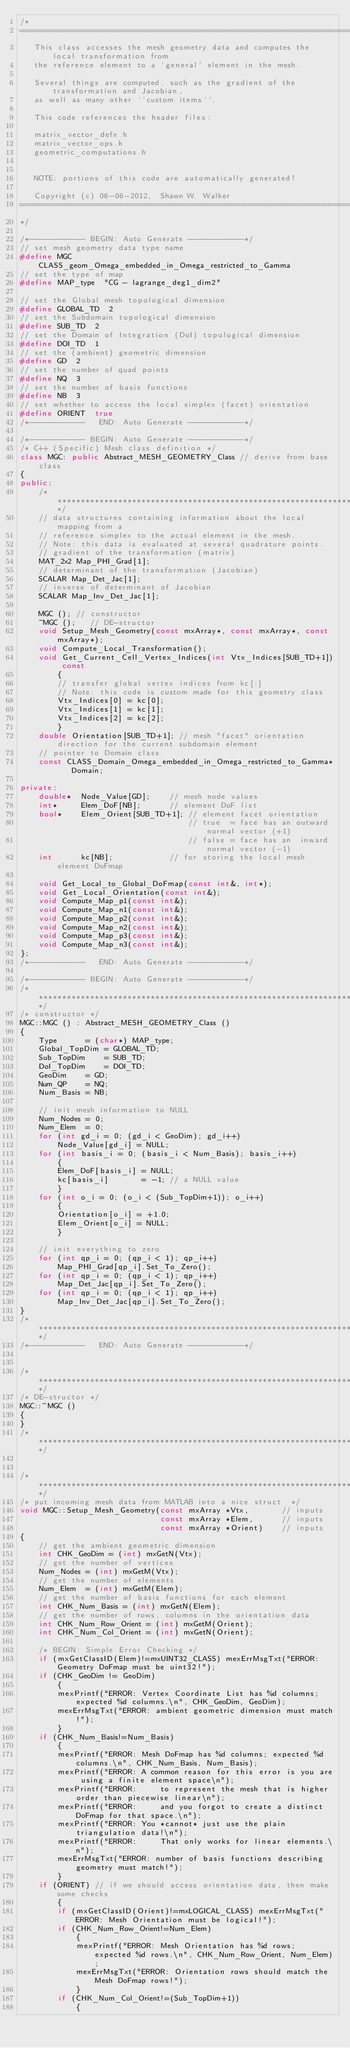<code> <loc_0><loc_0><loc_500><loc_500><_C++_>/*
============================================================================================
   This class accesses the mesh geometry data and computes the local transformation from
   the reference element to a `general' element in the mesh.
   
   Several things are computed, such as the gradient of the transformation and Jacobian,
   as well as many other ``custom items''.
   
   This code references the header files:
   
   matrix_vector_defn.h
   matrix_vector_ops.h
   geometric_computations.h
   

   NOTE: portions of this code are automatically generated!

   Copyright (c) 06-06-2012,  Shawn W. Walker
============================================================================================
*/

/*------------ BEGIN: Auto Generate ------------*/
// set mesh geometry data type name
#define MGC        CLASS_geom_Omega_embedded_in_Omega_restricted_to_Gamma
// set the type of map
#define MAP_type  "CG - lagrange_deg1_dim2"

// set the Global mesh topological dimension
#define GLOBAL_TD  2
// set the Subdomain topological dimension
#define SUB_TD  2
// set the Domain of Integration (DoI) topological dimension
#define DOI_TD  1
// set the (ambient) geometric dimension
#define GD  2
// set the number of quad points
#define NQ  3
// set the number of basis functions
#define NB  3
// set whether to access the local simplex (facet) orientation
#define ORIENT  true
/*------------   END: Auto Generate ------------*/

/*------------ BEGIN: Auto Generate ------------*/
/* C++ (Specific) Mesh class definition */
class MGC: public Abstract_MESH_GEOMETRY_Class // derive from base class
{
public:
    /***************************************************************************************/
    // data structures containing information about the local mapping from a
    // reference simplex to the actual element in the mesh.
    // Note: this data is evaluated at several quadrature points.
    // gradient of the transformation (matrix)
    MAT_2x2 Map_PHI_Grad[1];
    // determinant of the transformation (Jacobian)
    SCALAR Map_Det_Jac[1];
    // inverse of determinant of Jacobian
    SCALAR Map_Inv_Det_Jac[1];

    MGC (); // constructor
    ~MGC ();   // DE-structor
    void Setup_Mesh_Geometry(const mxArray*, const mxArray*, const mxArray*);
    void Compute_Local_Transformation();
    void Get_Current_Cell_Vertex_Indices(int Vtx_Indices[SUB_TD+1]) const
        {
        // transfer global vertex indices from kc[:]
        // Note: this code is custom made for this geometry class
        Vtx_Indices[0] = kc[0];
        Vtx_Indices[1] = kc[1];
        Vtx_Indices[2] = kc[2];
        }
    double Orientation[SUB_TD+1]; // mesh "facet" orientation direction for the current subdomain element
    // pointer to Domain class
    const CLASS_Domain_Omega_embedded_in_Omega_restricted_to_Gamma*   Domain;

private:
    double*  Node_Value[GD];    // mesh node values
    int*     Elem_DoF[NB];      // element DoF list
    bool*    Elem_Orient[SUB_TD+1]; // element facet orientation
                                    // true  = face has an outward normal vector (+1)
                                    // false = face has an  inward normal vector (-1)
    int      kc[NB];            // for storing the local mesh element DoFmap

    void Get_Local_to_Global_DoFmap(const int&, int*);
    void Get_Local_Orientation(const int&);
    void Compute_Map_p1(const int&);
    void Compute_Map_n1(const int&);
    void Compute_Map_p2(const int&);
    void Compute_Map_n2(const int&);
    void Compute_Map_p3(const int&);
    void Compute_Map_n3(const int&);
};
/*------------   END: Auto Generate ------------*/

/*------------ BEGIN: Auto Generate ------------*/
/***************************************************************************************/
/* constructor */
MGC::MGC () : Abstract_MESH_GEOMETRY_Class ()
{
    Type      = (char*) MAP_type;
    Global_TopDim = GLOBAL_TD;
    Sub_TopDim    = SUB_TD;
    DoI_TopDim    = DOI_TD;
    GeoDim    = GD;
    Num_QP    = NQ;
    Num_Basis = NB;

    // init mesh information to NULL
    Num_Nodes = 0;
    Num_Elem  = 0;
    for (int gd_i = 0; (gd_i < GeoDim); gd_i++)
        Node_Value[gd_i] = NULL;
    for (int basis_i = 0; (basis_i < Num_Basis); basis_i++)
        {
        Elem_DoF[basis_i] = NULL;
        kc[basis_i]       = -1; // a NULL value
        }
    for (int o_i = 0; (o_i < (Sub_TopDim+1)); o_i++)
        {
        Orientation[o_i] = +1.0;
        Elem_Orient[o_i] = NULL;
        }

    // init everything to zero
    for (int qp_i = 0; (qp_i < 1); qp_i++)
        Map_PHI_Grad[qp_i].Set_To_Zero();
    for (int qp_i = 0; (qp_i < 1); qp_i++)
        Map_Det_Jac[qp_i].Set_To_Zero();
    for (int qp_i = 0; (qp_i < 1); qp_i++)
        Map_Inv_Det_Jac[qp_i].Set_To_Zero();
}
/***************************************************************************************/
/*------------   END: Auto Generate ------------*/


/***************************************************************************************/
/* DE-structor */
MGC::~MGC ()
{
}
/***************************************************************************************/


/***************************************************************************************/
/* put incoming mesh data from MATLAB into a nice struct  */
void MGC::Setup_Mesh_Geometry(const mxArray *Vtx,       // inputs
                              const mxArray *Elem,      // inputs
                              const mxArray *Orient)    // inputs
{
    // get the ambient geometric dimension
    int CHK_GeoDim = (int) mxGetN(Vtx);
    // get the number of vertices
    Num_Nodes = (int) mxGetM(Vtx);
    // get the number of elements
    Num_Elem  = (int) mxGetM(Elem);
    // get the number of basis functions for each element
    int CHK_Num_Basis = (int) mxGetN(Elem);
    // get the number of rows, columns in the orientation data
    int CHK_Num_Row_Orient = (int) mxGetM(Orient);
    int CHK_Num_Col_Orient = (int) mxGetN(Orient);

    /* BEGIN: Simple Error Checking */
    if (mxGetClassID(Elem)!=mxUINT32_CLASS) mexErrMsgTxt("ERROR: Geometry DoFmap must be uint32!");
    if (CHK_GeoDim != GeoDim)
        {
        mexPrintf("ERROR: Vertex Coordinate List has %d columns; expected %d columns.\n", CHK_GeoDim, GeoDim);
        mexErrMsgTxt("ERROR: ambient geometric dimension must match!");
        }
    if (CHK_Num_Basis!=Num_Basis)
        {
        mexPrintf("ERROR: Mesh DoFmap has %d columns; expected %d columns.\n", CHK_Num_Basis, Num_Basis);
        mexPrintf("ERROR: A common reason for this error is you are using a finite element space\n");
        mexPrintf("ERROR:     to represent the mesh that is higher order than piecewise linear\n");
        mexPrintf("ERROR:     and you forgot to create a distinct DoFmap for that space.\n");
        mexPrintf("ERROR: You *cannot* just use the plain triangulation data!\n");
        mexPrintf("ERROR:     That only works for linear elements.\n");
        mexErrMsgTxt("ERROR: number of basis functions describing geometry must match!");
        }
    if (ORIENT) // if we should access orientation data, then make some checks
        {
        if (mxGetClassID(Orient)!=mxLOGICAL_CLASS) mexErrMsgTxt("ERROR: Mesh Orientation must be logical!");
        if (CHK_Num_Row_Orient!=Num_Elem)
            {
            mexPrintf("ERROR: Mesh Orientation has %d rows; expected %d rows.\n", CHK_Num_Row_Orient, Num_Elem);
            mexErrMsgTxt("ERROR: Orientation rows should match the Mesh DoFmap rows!");
            }
        if (CHK_Num_Col_Orient!=(Sub_TopDim+1))
            {</code> 